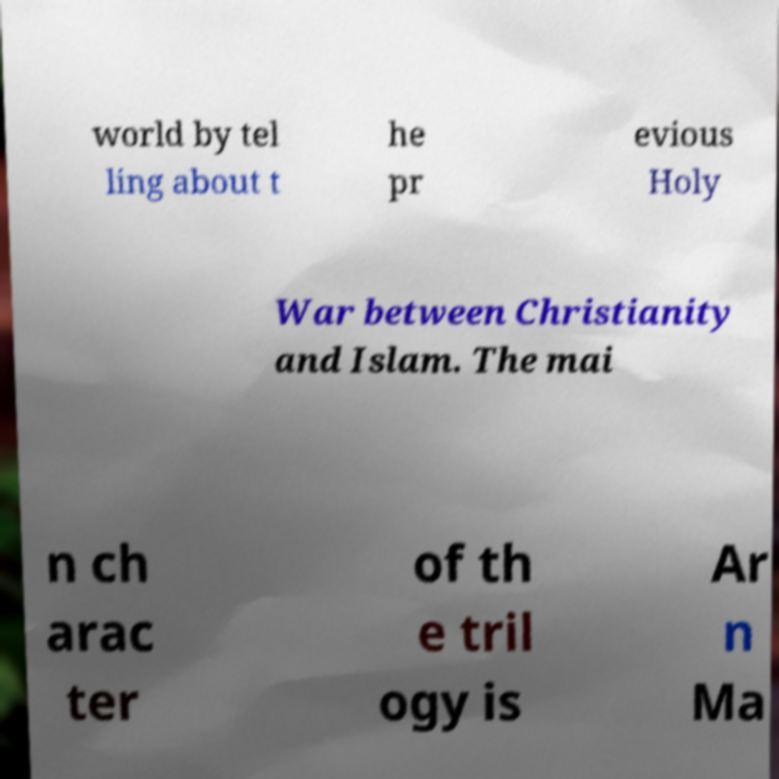Can you read and provide the text displayed in the image?This photo seems to have some interesting text. Can you extract and type it out for me? world by tel ling about t he pr evious Holy War between Christianity and Islam. The mai n ch arac ter of th e tril ogy is Ar n Ma 